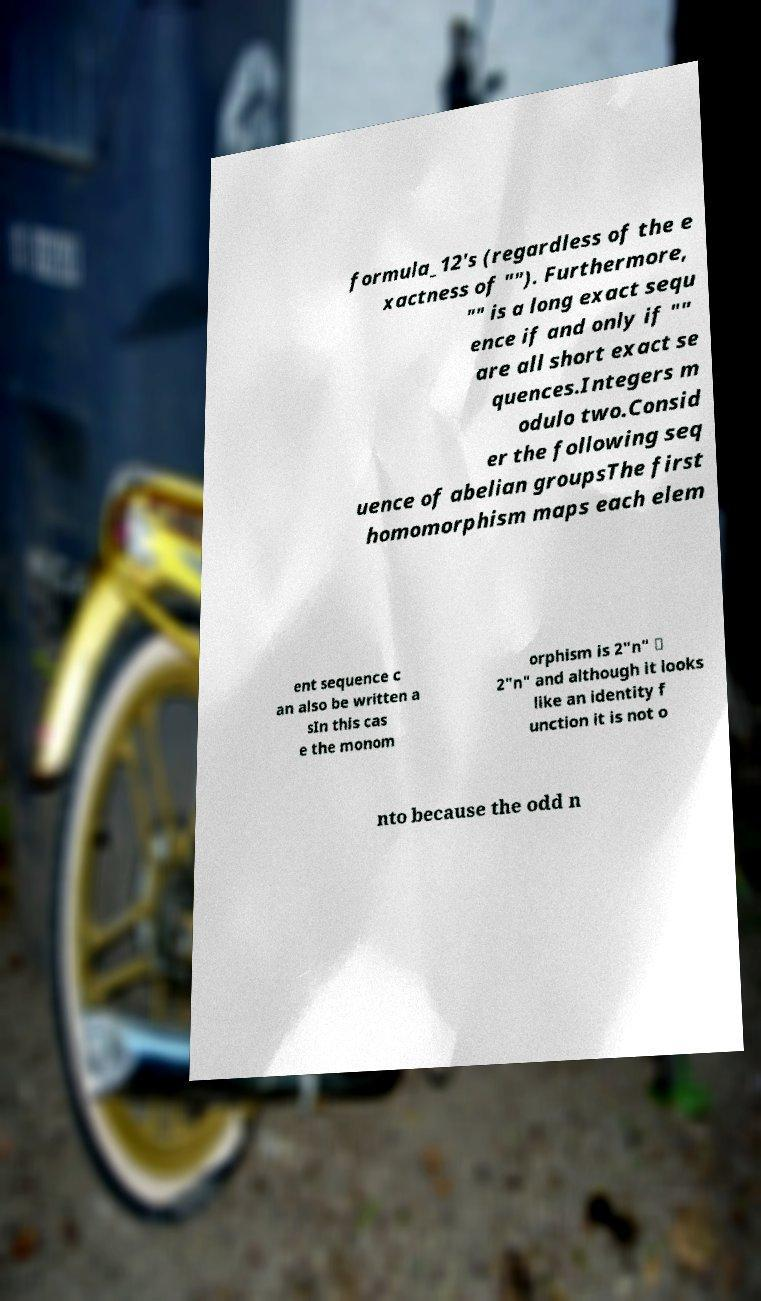I need the written content from this picture converted into text. Can you do that? formula_12's (regardless of the e xactness of ""). Furthermore, "" is a long exact sequ ence if and only if "" are all short exact se quences.Integers m odulo two.Consid er the following seq uence of abelian groupsThe first homomorphism maps each elem ent sequence c an also be written a sIn this cas e the monom orphism is 2"n" ↦ 2"n" and although it looks like an identity f unction it is not o nto because the odd n 